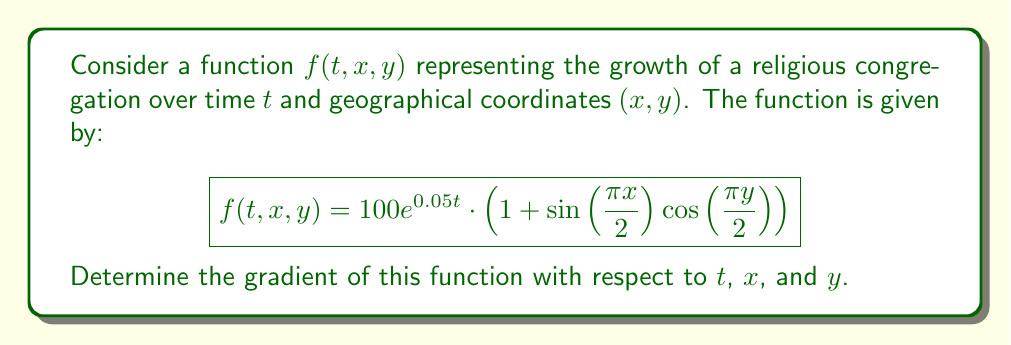Can you solve this math problem? To find the gradient of the function $f(t, x, y)$, we need to calculate the partial derivatives with respect to each variable:

1. Partial derivative with respect to $t$:
   $$\frac{\partial f}{\partial t} = 5e^{0.05t} \cdot (1 + \sin(\frac{\pi x}{2}) \cos(\frac{\pi y}{2}))$$

2. Partial derivative with respect to $x$:
   $$\frac{\partial f}{\partial x} = 100e^{0.05t} \cdot (\frac{\pi}{2} \cos(\frac{\pi x}{2}) \cos(\frac{\pi y}{2}))$$

3. Partial derivative with respect to $y$:
   $$\frac{\partial f}{\partial y} = 100e^{0.05t} \cdot (-\frac{\pi}{2} \sin(\frac{\pi x}{2}) \sin(\frac{\pi y}{2}))$$

The gradient is a vector-valued function that combines these partial derivatives:

$$\nabla f(t, x, y) = \left(\frac{\partial f}{\partial t}, \frac{\partial f}{\partial x}, \frac{\partial f}{\partial y}\right)$$

Therefore, the gradient of the function is:

$$\nabla f(t, x, y) = \left(5e^{0.05t} \cdot (1 + \sin(\frac{\pi x}{2}) \cos(\frac{\pi y}{2})), 100e^{0.05t} \cdot (\frac{\pi}{2} \cos(\frac{\pi x}{2}) \cos(\frac{\pi y}{2})), 100e^{0.05t} \cdot (-\frac{\pi}{2} \sin(\frac{\pi x}{2}) \sin(\frac{\pi y}{2}))\right)$$
Answer: $$\nabla f(t, x, y) = \left(5e^{0.05t} \cdot (1 + \sin(\frac{\pi x}{2}) \cos(\frac{\pi y}{2})), 100e^{0.05t} \cdot (\frac{\pi}{2} \cos(\frac{\pi x}{2}) \cos(\frac{\pi y}{2})), 100e^{0.05t} \cdot (-\frac{\pi}{2} \sin(\frac{\pi x}{2}) \sin(\frac{\pi y}{2}))\right)$$ 